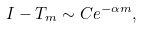Convert formula to latex. <formula><loc_0><loc_0><loc_500><loc_500>I - T _ { m } \sim C e ^ { - \alpha m } ,</formula> 